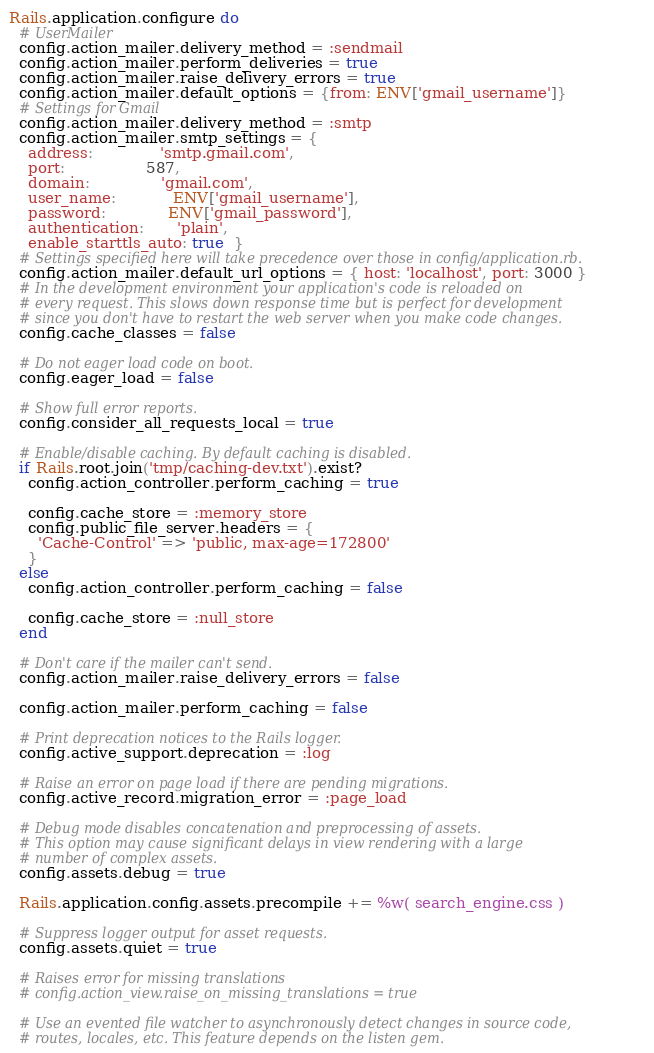<code> <loc_0><loc_0><loc_500><loc_500><_Ruby_>Rails.application.configure do
  # UserMailer
  config.action_mailer.delivery_method = :sendmail
  config.action_mailer.perform_deliveries = true
  config.action_mailer.raise_delivery_errors = true
  config.action_mailer.default_options = {from: ENV['gmail_username']}
  # Settings for Gmail
  config.action_mailer.delivery_method = :smtp
  config.action_mailer.smtp_settings = {
    address:              'smtp.gmail.com',
    port:                 587,
    domain:               'gmail.com',
    user_name:            ENV['gmail_username'],
    password:             ENV['gmail_password'],
    authentication:       'plain',
    enable_starttls_auto: true  }
  # Settings specified here will take precedence over those in config/application.rb.
  config.action_mailer.default_url_options = { host: 'localhost', port: 3000 }
  # In the development environment your application's code is reloaded on
  # every request. This slows down response time but is perfect for development
  # since you don't have to restart the web server when you make code changes.
  config.cache_classes = false

  # Do not eager load code on boot.
  config.eager_load = false

  # Show full error reports.
  config.consider_all_requests_local = true

  # Enable/disable caching. By default caching is disabled.
  if Rails.root.join('tmp/caching-dev.txt').exist?
    config.action_controller.perform_caching = true

    config.cache_store = :memory_store
    config.public_file_server.headers = {
      'Cache-Control' => 'public, max-age=172800'
    }
  else
    config.action_controller.perform_caching = false

    config.cache_store = :null_store
  end

  # Don't care if the mailer can't send.
  config.action_mailer.raise_delivery_errors = false

  config.action_mailer.perform_caching = false

  # Print deprecation notices to the Rails logger.
  config.active_support.deprecation = :log

  # Raise an error on page load if there are pending migrations.
  config.active_record.migration_error = :page_load

  # Debug mode disables concatenation and preprocessing of assets.
  # This option may cause significant delays in view rendering with a large
  # number of complex assets.
  config.assets.debug = true

  Rails.application.config.assets.precompile += %w( search_engine.css )

  # Suppress logger output for asset requests.
  config.assets.quiet = true

  # Raises error for missing translations
  # config.action_view.raise_on_missing_translations = true

  # Use an evented file watcher to asynchronously detect changes in source code,
  # routes, locales, etc. This feature depends on the listen gem.</code> 